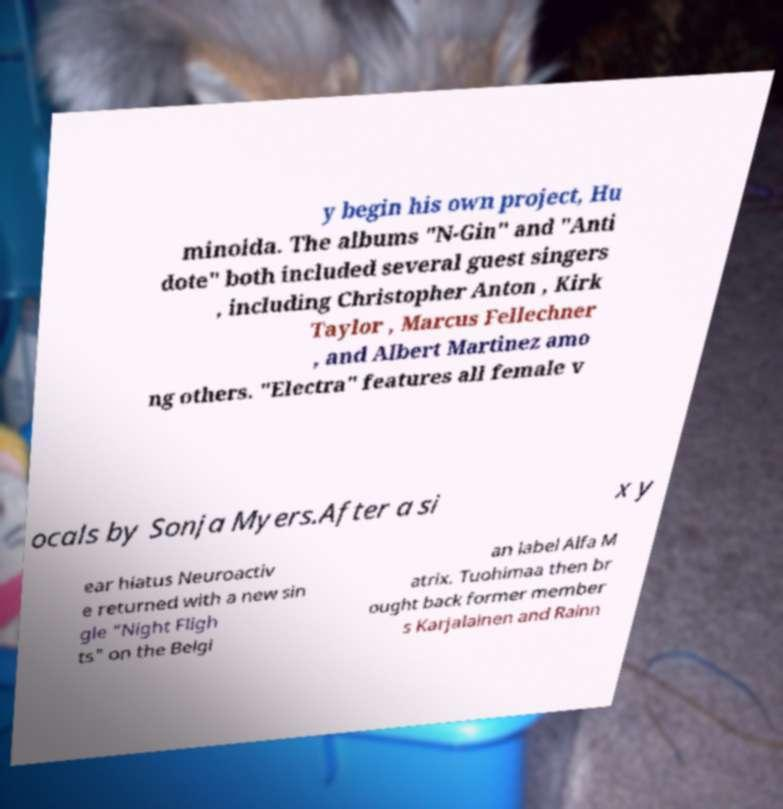I need the written content from this picture converted into text. Can you do that? y begin his own project, Hu minoida. The albums "N-Gin" and "Anti dote" both included several guest singers , including Christopher Anton , Kirk Taylor , Marcus Fellechner , and Albert Martinez amo ng others. "Electra" features all female v ocals by Sonja Myers.After a si x y ear hiatus Neuroactiv e returned with a new sin gle "Night Fligh ts" on the Belgi an label Alfa M atrix. Tuohimaa then br ought back former member s Karjalainen and Rainn 